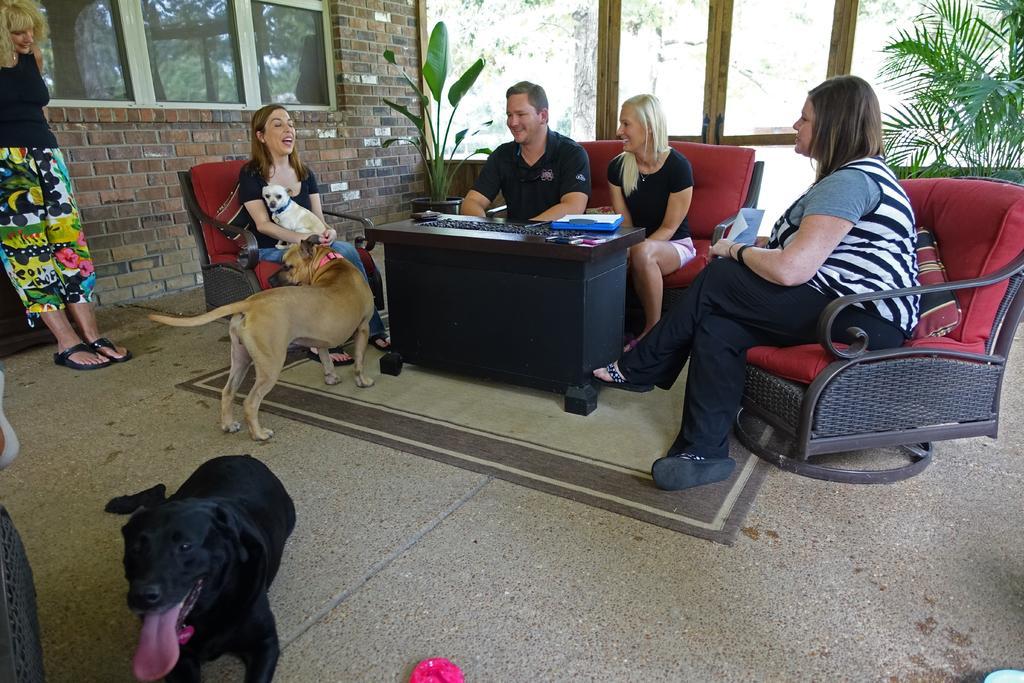Can you describe this image briefly? people are sitting on the sofa. in front of it there is a table. in the front there are 2 dogs. at the left a person is standing. the person sitting on the left is holding a dog. behind there is a brick wall and windows. at the back there are glass doors and plants. 